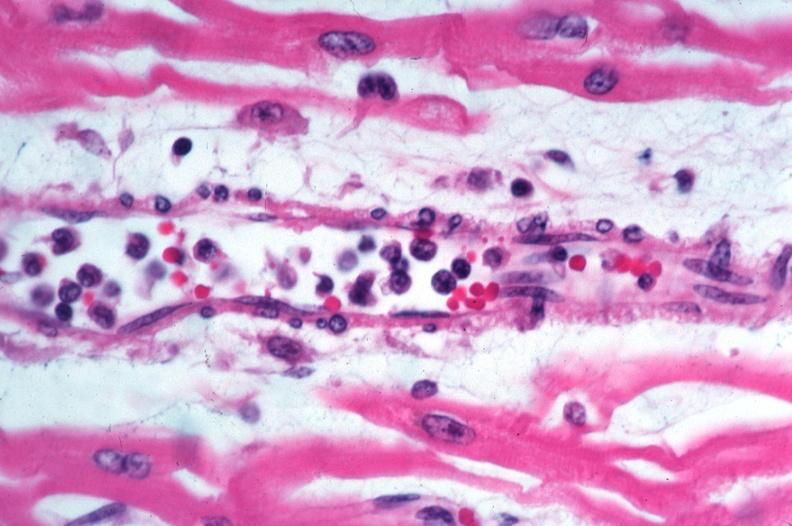what is rocky mountain spotted?
Answer the question using a single word or phrase. Fever 